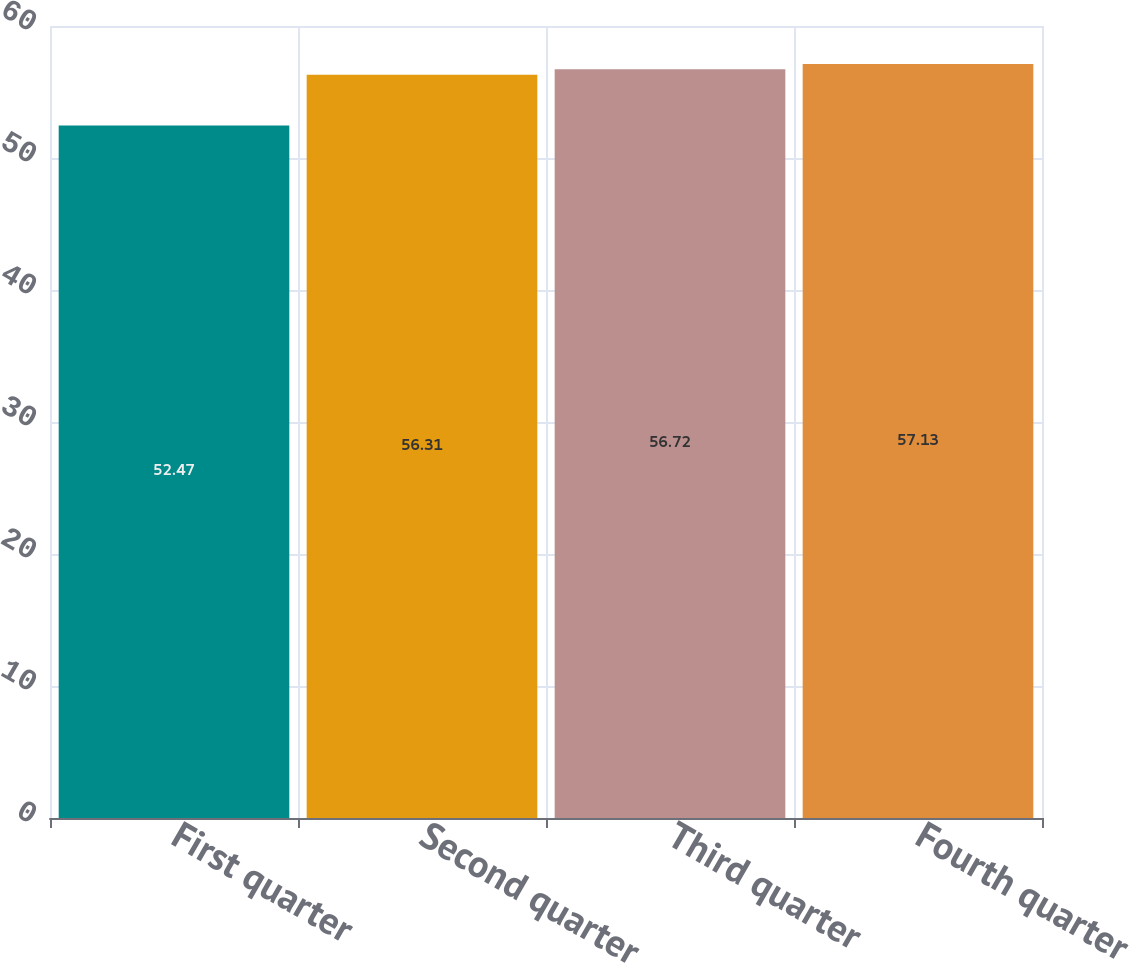Convert chart to OTSL. <chart><loc_0><loc_0><loc_500><loc_500><bar_chart><fcel>First quarter<fcel>Second quarter<fcel>Third quarter<fcel>Fourth quarter<nl><fcel>52.47<fcel>56.31<fcel>56.72<fcel>57.13<nl></chart> 